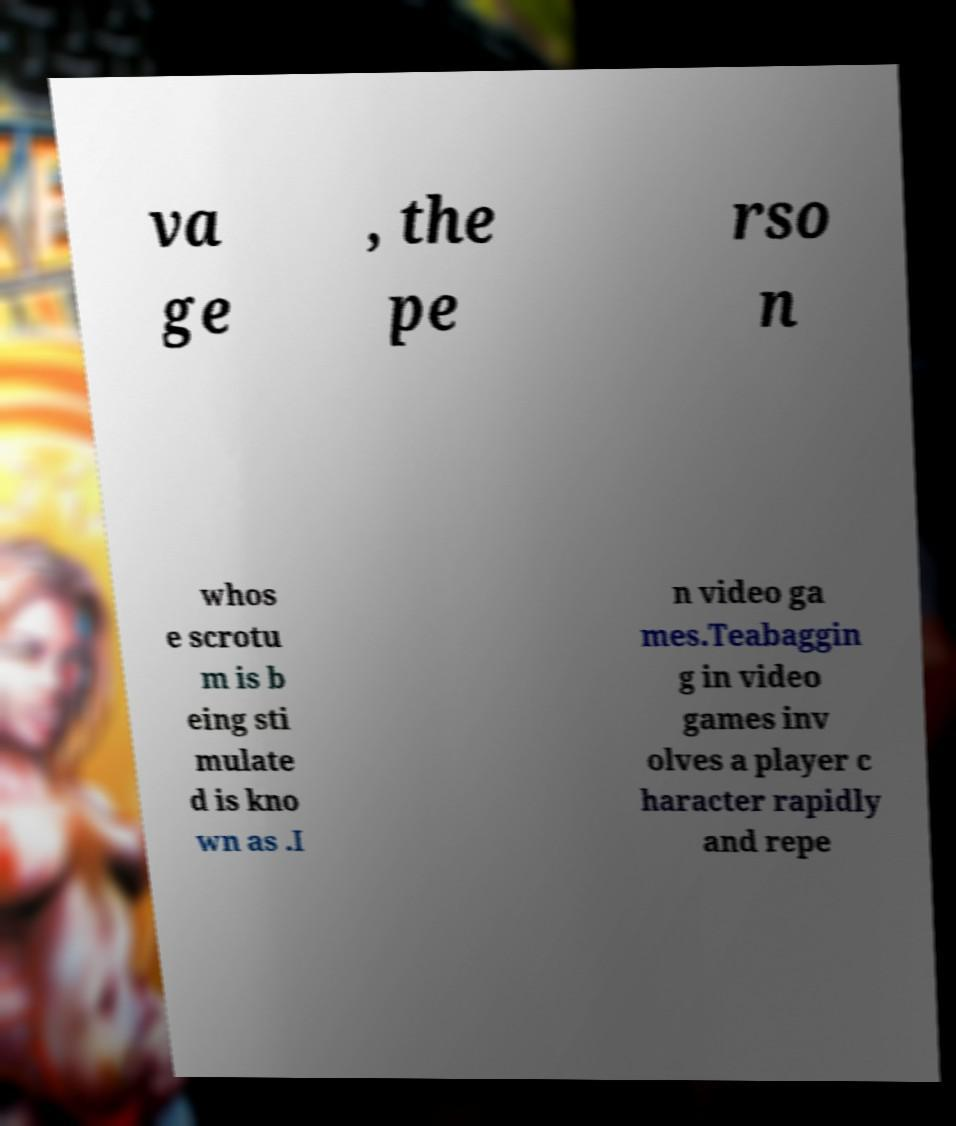Can you accurately transcribe the text from the provided image for me? va ge , the pe rso n whos e scrotu m is b eing sti mulate d is kno wn as .I n video ga mes.Teabaggin g in video games inv olves a player c haracter rapidly and repe 